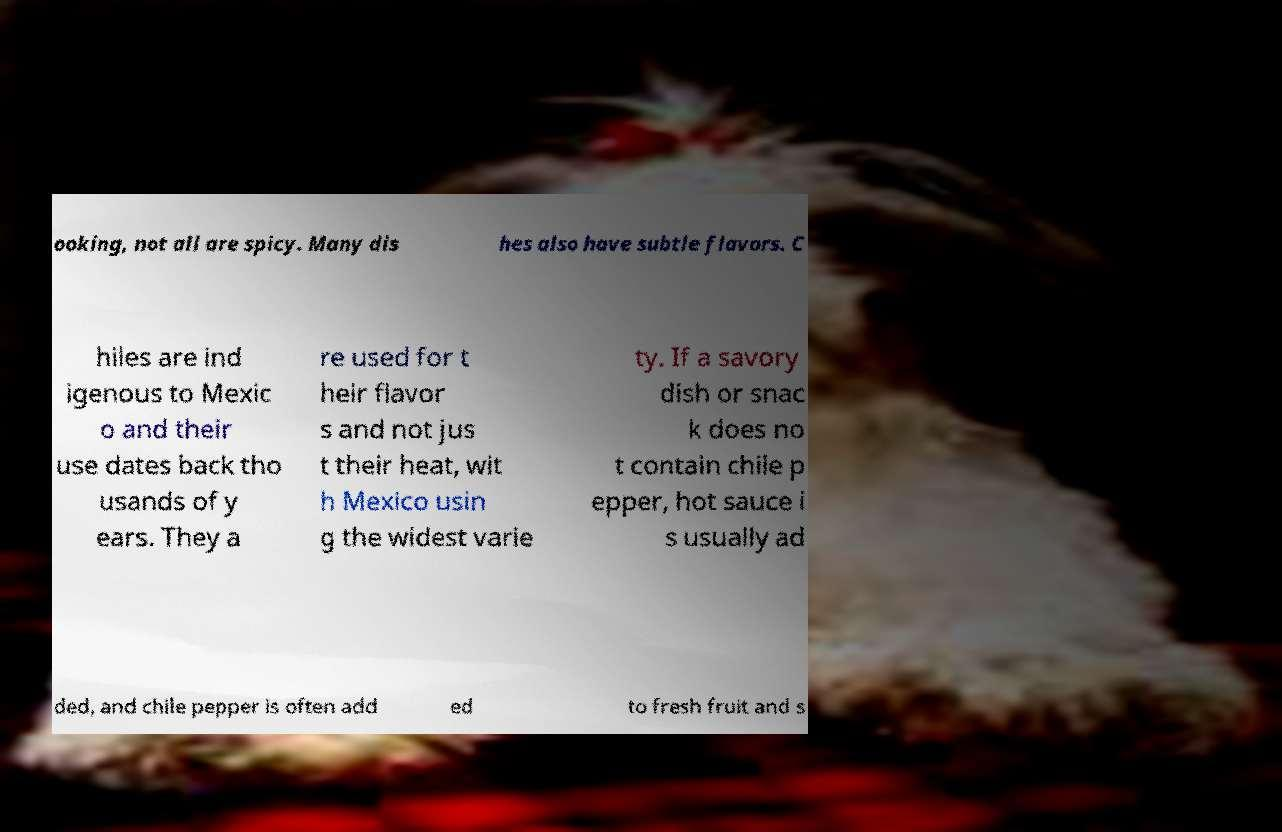What messages or text are displayed in this image? I need them in a readable, typed format. ooking, not all are spicy. Many dis hes also have subtle flavors. C hiles are ind igenous to Mexic o and their use dates back tho usands of y ears. They a re used for t heir flavor s and not jus t their heat, wit h Mexico usin g the widest varie ty. If a savory dish or snac k does no t contain chile p epper, hot sauce i s usually ad ded, and chile pepper is often add ed to fresh fruit and s 